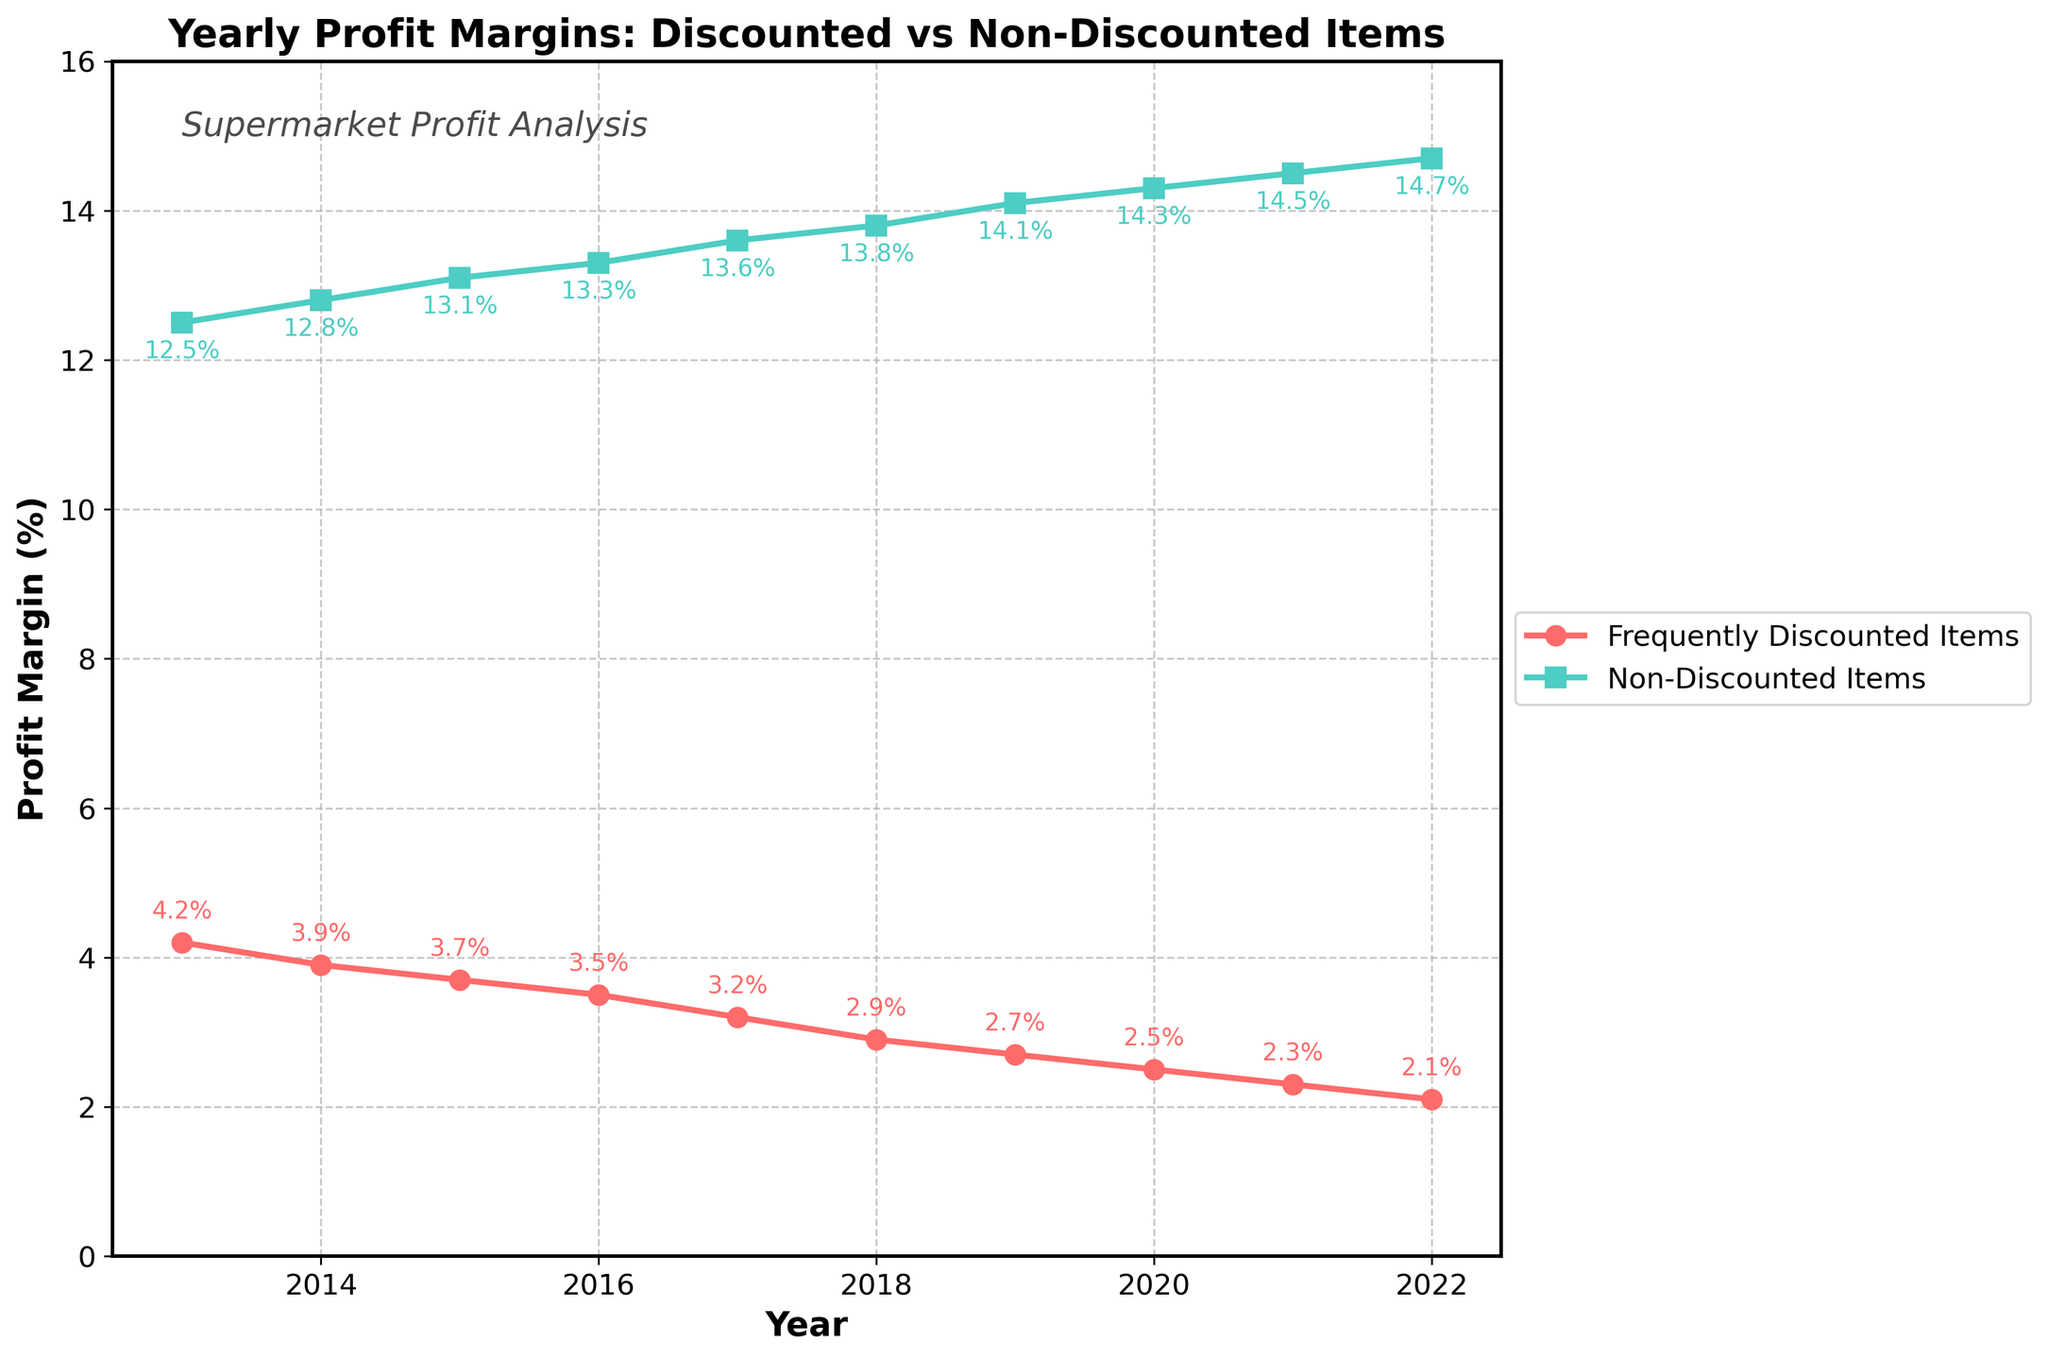How does the profit margin of frequently discounted items change from 2013 to 2022? According to the figure, we see the red line declining. The profit margin for frequently discounted items starts at 4.2% in 2013 and drops to 2.1% in 2022.
Answer: Decreases from 4.2% to 2.1% Is there any year where the profit margins for frequently discounted items and non-discounted items are equal? From the figure, we can see that the lines for the two categories never intersect, meaning their profit margins are never equal in any year.
Answer: No By how much did the profit margin for non-discounted items increase between 2013 and 2022? The profit margin for non-discounted items increased from 12.5% in 2013 to 14.7% in 2022. The difference is 14.7% - 12.5% = 2.2%.
Answer: 2.2% What is the difference in profit margins between non-discounted items and frequently discounted items in 2022? In 2022, the profit margin for non-discounted items is 14.7% and for frequently discounted items is 2.1%. The difference is 14.7% - 2.1% = 12.6%.
Answer: 12.6% In which years did the profit margins for frequently discounted items decrease by more than 0.2% compared to the previous year? Analyzing the red line, profit margins for frequently discounted items decreased by more than 0.2% from 2013 to 2014 (4.2% to 3.9%), 2016 to 2017 (3.5% to 3.2%), and 2017 to 2018 (3.2% to 2.9%).
Answer: 2013-2014, 2016-2017, 2017-2018 Between 2015 and 2020, how did the trends of profit margins differ for the two categories? From 2015 to 2020, the profit margin for frequently discounted items (red line) shows a consistent downward trend from 3.7% to 2.5%. On the other hand, the profit margin for non-discounted items (green line) consistently increased from 13.1% to 14.3%.
Answer: Frequently discounted items decreased, non-discounted items increased What visual elements help distinguish the two lines representing frequently discounted items and non-discounted items? The red line with circular markers represents frequently discounted items, while the green line with square markers represents non-discounted items. Both lines are also labeled in the legend.
Answer: Color, marker shape, legend Which item category had a better average profit margin over the 10-year period from 2013 to 2022, and what is the average? The average profit margin for frequently discounted items (red line) is calculated as (4.2 + 3.9 + 3.7 + 3.5 + 3.2 + 2.9 + 2.7 + 2.5 + 2.3 + 2.1) / 10 = 3.1%. For non-discounted items (green line), it is (12.5 + 12.8 + 13.1 + 13.3 + 13.6 + 13.8 + 14.1 + 14.3 + 14.5 + 14.7) / 10 = 13.67%. Non-discounted items had a better average profit margin.
Answer: Non-discounted items, 13.67% 